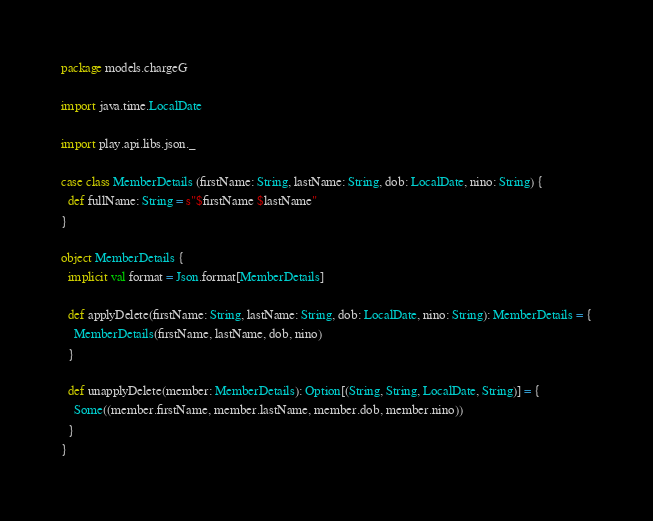Convert code to text. <code><loc_0><loc_0><loc_500><loc_500><_Scala_>
package models.chargeG

import java.time.LocalDate

import play.api.libs.json._

case class MemberDetails (firstName: String, lastName: String, dob: LocalDate, nino: String) {
  def fullName: String = s"$firstName $lastName"
}

object MemberDetails {
  implicit val format = Json.format[MemberDetails]

  def applyDelete(firstName: String, lastName: String, dob: LocalDate, nino: String): MemberDetails = {
    MemberDetails(firstName, lastName, dob, nino)
  }

  def unapplyDelete(member: MemberDetails): Option[(String, String, LocalDate, String)] = {
    Some((member.firstName, member.lastName, member.dob, member.nino))
  }
}
</code> 